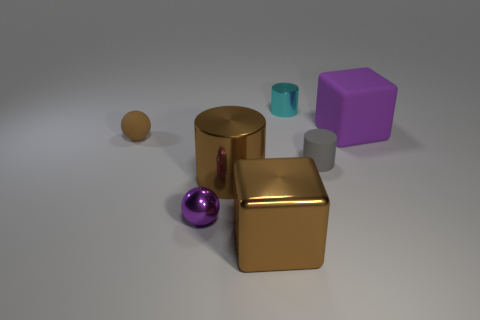What color is the big block that is behind the tiny matte thing on the left side of the small thing that is behind the matte sphere?
Offer a terse response. Purple. Is there a brown object that is behind the tiny purple metallic sphere that is on the left side of the large brown cube?
Offer a very short reply. Yes. Is the shape of the matte thing that is to the left of the cyan object the same as  the purple rubber thing?
Provide a succinct answer. No. What number of cylinders are either large brown things or tiny gray objects?
Offer a very short reply. 2. What number of brown rubber spheres are there?
Ensure brevity in your answer.  1. There is a cube that is to the right of the matte thing that is in front of the tiny brown rubber object; what is its size?
Provide a succinct answer. Large. How many other things are the same size as the purple matte object?
Make the answer very short. 2. How many cubes are to the left of the cyan cylinder?
Offer a very short reply. 1. The brown rubber object has what size?
Ensure brevity in your answer.  Small. Does the small cyan cylinder that is behind the tiny metal sphere have the same material as the large brown thing behind the purple shiny ball?
Offer a very short reply. Yes. 